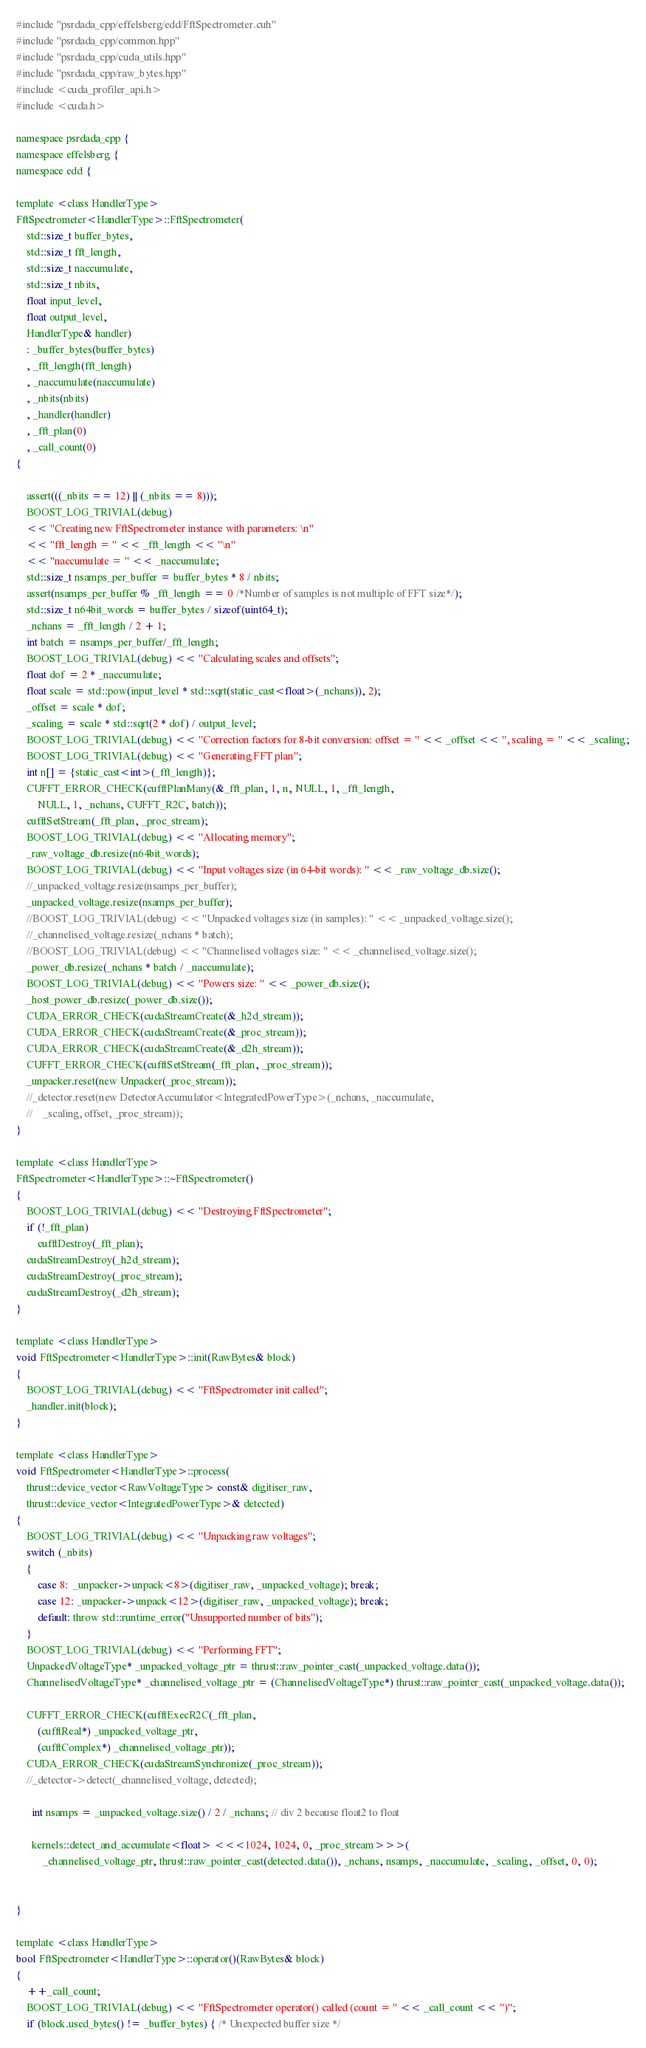<code> <loc_0><loc_0><loc_500><loc_500><_Cuda_>#include "psrdada_cpp/effelsberg/edd/FftSpectrometer.cuh"
#include "psrdada_cpp/common.hpp"
#include "psrdada_cpp/cuda_utils.hpp"
#include "psrdada_cpp/raw_bytes.hpp"
#include <cuda_profiler_api.h>
#include <cuda.h>

namespace psrdada_cpp {
namespace effelsberg {
namespace edd {

template <class HandlerType>
FftSpectrometer<HandlerType>::FftSpectrometer(
    std::size_t buffer_bytes,
    std::size_t fft_length,
    std::size_t naccumulate,
    std::size_t nbits,
    float input_level,
    float output_level,
    HandlerType& handler)
    : _buffer_bytes(buffer_bytes)
    , _fft_length(fft_length)
    , _naccumulate(naccumulate)
    , _nbits(nbits)
    , _handler(handler)
    , _fft_plan(0)
    , _call_count(0)
{

    assert(((_nbits == 12) || (_nbits == 8)));
    BOOST_LOG_TRIVIAL(debug)
    << "Creating new FftSpectrometer instance with parameters: \n"
    << "fft_length = " << _fft_length << "\n"
    << "naccumulate = " << _naccumulate;
    std::size_t nsamps_per_buffer = buffer_bytes * 8 / nbits;
    assert(nsamps_per_buffer % _fft_length == 0 /*Number of samples is not multiple of FFT size*/);
    std::size_t n64bit_words = buffer_bytes / sizeof(uint64_t);
    _nchans = _fft_length / 2 + 1;
    int batch = nsamps_per_buffer/_fft_length;
    BOOST_LOG_TRIVIAL(debug) << "Calculating scales and offsets";
    float dof = 2 * _naccumulate;
    float scale = std::pow(input_level * std::sqrt(static_cast<float>(_nchans)), 2);
    _offset = scale * dof;
    _scaling = scale * std::sqrt(2 * dof) / output_level;
    BOOST_LOG_TRIVIAL(debug) << "Correction factors for 8-bit conversion: offset = " << _offset << ", scaling = " << _scaling;
    BOOST_LOG_TRIVIAL(debug) << "Generating FFT plan";
    int n[] = {static_cast<int>(_fft_length)};
    CUFFT_ERROR_CHECK(cufftPlanMany(&_fft_plan, 1, n, NULL, 1, _fft_length,
        NULL, 1, _nchans, CUFFT_R2C, batch));
    cufftSetStream(_fft_plan, _proc_stream);
    BOOST_LOG_TRIVIAL(debug) << "Allocating memory";
    _raw_voltage_db.resize(n64bit_words);
    BOOST_LOG_TRIVIAL(debug) << "Input voltages size (in 64-bit words): " << _raw_voltage_db.size();
    //_unpacked_voltage.resize(nsamps_per_buffer);
    _unpacked_voltage.resize(nsamps_per_buffer);
    //BOOST_LOG_TRIVIAL(debug) << "Unpacked voltages size (in samples): " << _unpacked_voltage.size();
    //_channelised_voltage.resize(_nchans * batch);
    //BOOST_LOG_TRIVIAL(debug) << "Channelised voltages size: " << _channelised_voltage.size();
    _power_db.resize(_nchans * batch / _naccumulate);
    BOOST_LOG_TRIVIAL(debug) << "Powers size: " << _power_db.size();
    _host_power_db.resize(_power_db.size());
    CUDA_ERROR_CHECK(cudaStreamCreate(&_h2d_stream));
    CUDA_ERROR_CHECK(cudaStreamCreate(&_proc_stream));
    CUDA_ERROR_CHECK(cudaStreamCreate(&_d2h_stream));
    CUFFT_ERROR_CHECK(cufftSetStream(_fft_plan, _proc_stream));
    _unpacker.reset(new Unpacker(_proc_stream));
    //_detector.reset(new DetectorAccumulator<IntegratedPowerType>(_nchans, _naccumulate,
    //    _scaling, offset, _proc_stream));
}

template <class HandlerType>
FftSpectrometer<HandlerType>::~FftSpectrometer()
{
    BOOST_LOG_TRIVIAL(debug) << "Destroying FftSpectrometer";
    if (!_fft_plan)
        cufftDestroy(_fft_plan);
    cudaStreamDestroy(_h2d_stream);
    cudaStreamDestroy(_proc_stream);
    cudaStreamDestroy(_d2h_stream);
}

template <class HandlerType>
void FftSpectrometer<HandlerType>::init(RawBytes& block)
{
    BOOST_LOG_TRIVIAL(debug) << "FftSpectrometer init called";
    _handler.init(block);
}

template <class HandlerType>
void FftSpectrometer<HandlerType>::process(
    thrust::device_vector<RawVoltageType> const& digitiser_raw,
    thrust::device_vector<IntegratedPowerType>& detected)
{
    BOOST_LOG_TRIVIAL(debug) << "Unpacking raw voltages";
    switch (_nbits)
    {
        case 8:  _unpacker->unpack<8>(digitiser_raw, _unpacked_voltage); break;
        case 12: _unpacker->unpack<12>(digitiser_raw, _unpacked_voltage); break;
        default: throw std::runtime_error("Unsupported number of bits");
    }
    BOOST_LOG_TRIVIAL(debug) << "Performing FFT";
    UnpackedVoltageType* _unpacked_voltage_ptr = thrust::raw_pointer_cast(_unpacked_voltage.data());
    ChannelisedVoltageType* _channelised_voltage_ptr = (ChannelisedVoltageType*) thrust::raw_pointer_cast(_unpacked_voltage.data());

    CUFFT_ERROR_CHECK(cufftExecR2C(_fft_plan,
        (cufftReal*) _unpacked_voltage_ptr,
        (cufftComplex*) _channelised_voltage_ptr));
    CUDA_ERROR_CHECK(cudaStreamSynchronize(_proc_stream));
    //_detector->detect(_channelised_voltage, detected);

      int nsamps = _unpacked_voltage.size() / 2 / _nchans; // div 2 because float2 to float

      kernels::detect_and_accumulate<float> <<<1024, 1024, 0, _proc_stream>>>(
          _channelised_voltage_ptr, thrust::raw_pointer_cast(detected.data()), _nchans, nsamps, _naccumulate, _scaling, _offset, 0, 0);


}

template <class HandlerType>
bool FftSpectrometer<HandlerType>::operator()(RawBytes& block)
{
    ++_call_count;
    BOOST_LOG_TRIVIAL(debug) << "FftSpectrometer operator() called (count = " << _call_count << ")";
    if (block.used_bytes() != _buffer_bytes) { /* Unexpected buffer size */</code> 